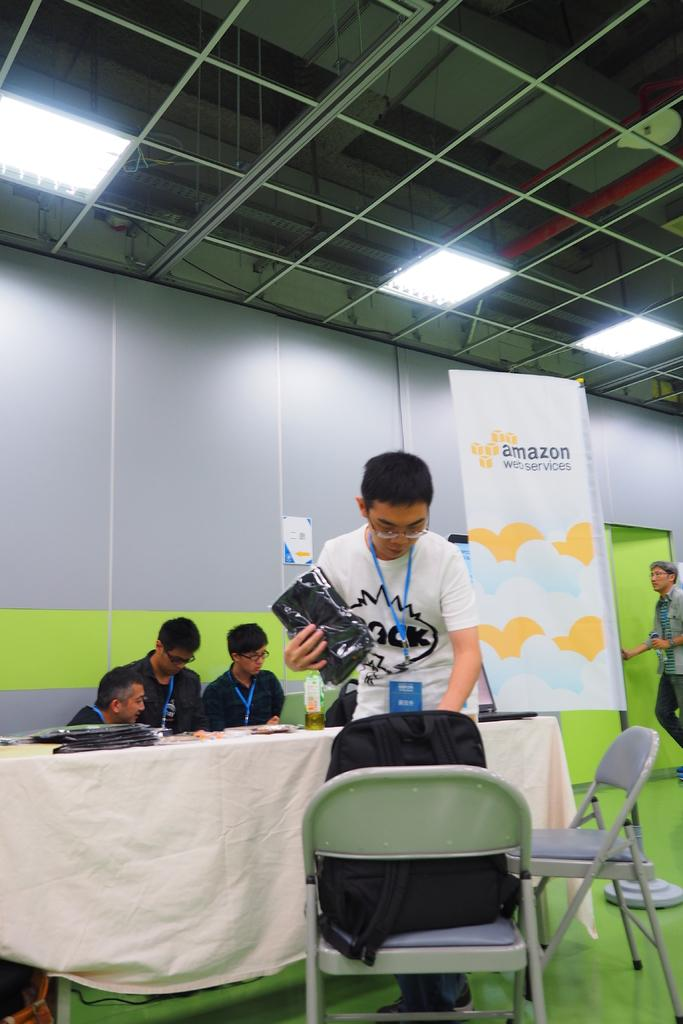Who or what can be seen in the image? There are people in the image. Can you describe the position of the bag in the image? A bag is on a chair in the image. What are some people doing in the image? Some people are sitting in front of a table. What can be seen in the background of the image? There is a banner in the background. What type of shame is depicted on the banner in the image? There is no shame depicted on the banner in the image; it is not mentioned in the provided facts. How many giants can be seen in the image? There are no giants present in the image. 